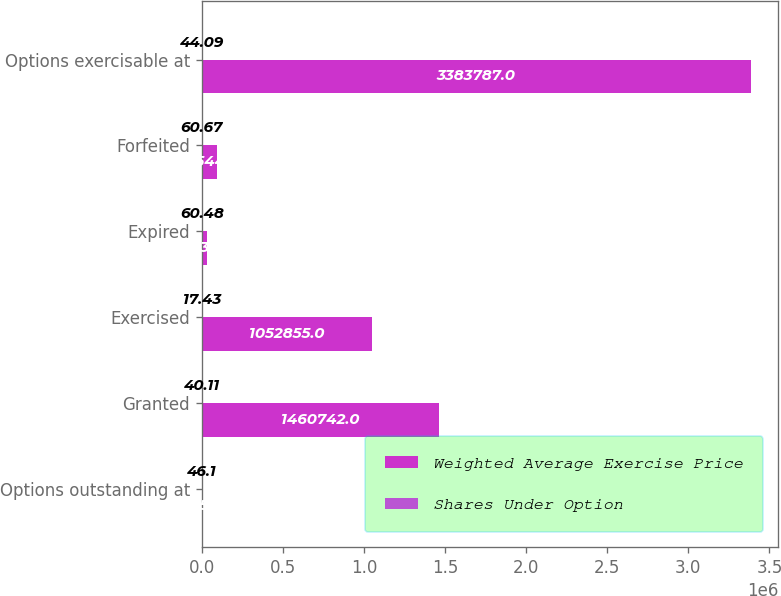<chart> <loc_0><loc_0><loc_500><loc_500><stacked_bar_chart><ecel><fcel>Options outstanding at<fcel>Granted<fcel>Exercised<fcel>Expired<fcel>Forfeited<fcel>Options exercisable at<nl><fcel>Weighted Average Exercise Price<fcel>60.575<fcel>1.46074e+06<fcel>1.05286e+06<fcel>34137<fcel>92544<fcel>3.38379e+06<nl><fcel>Shares Under Option<fcel>46.1<fcel>40.11<fcel>17.43<fcel>60.48<fcel>60.67<fcel>44.09<nl></chart> 